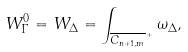Convert formula to latex. <formula><loc_0><loc_0><loc_500><loc_500>W _ { \Gamma } ^ { 0 } = W _ { \Delta } = \int _ { \overline { C _ { n + 1 , m } } ^ { + } } \omega _ { \Delta } ,</formula> 